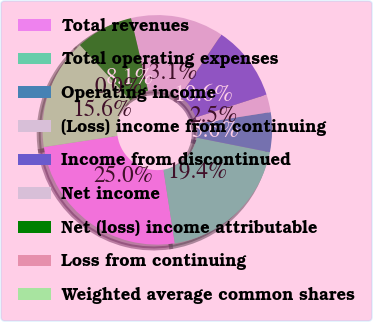Convert chart. <chart><loc_0><loc_0><loc_500><loc_500><pie_chart><fcel>Total revenues<fcel>Total operating expenses<fcel>Operating income<fcel>(Loss) income from continuing<fcel>Income from discontinued<fcel>Net income<fcel>Net (loss) income attributable<fcel>Loss from continuing<fcel>Weighted average common shares<nl><fcel>25.04%<fcel>19.44%<fcel>5.6%<fcel>2.5%<fcel>10.6%<fcel>13.11%<fcel>8.1%<fcel>0.0%<fcel>15.61%<nl></chart> 